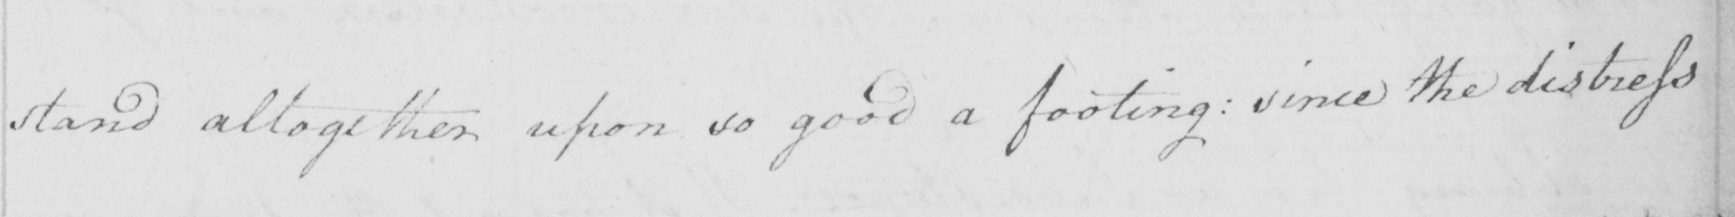Transcribe the text shown in this historical manuscript line. stand altogether upon so good a footing :  since the distress 